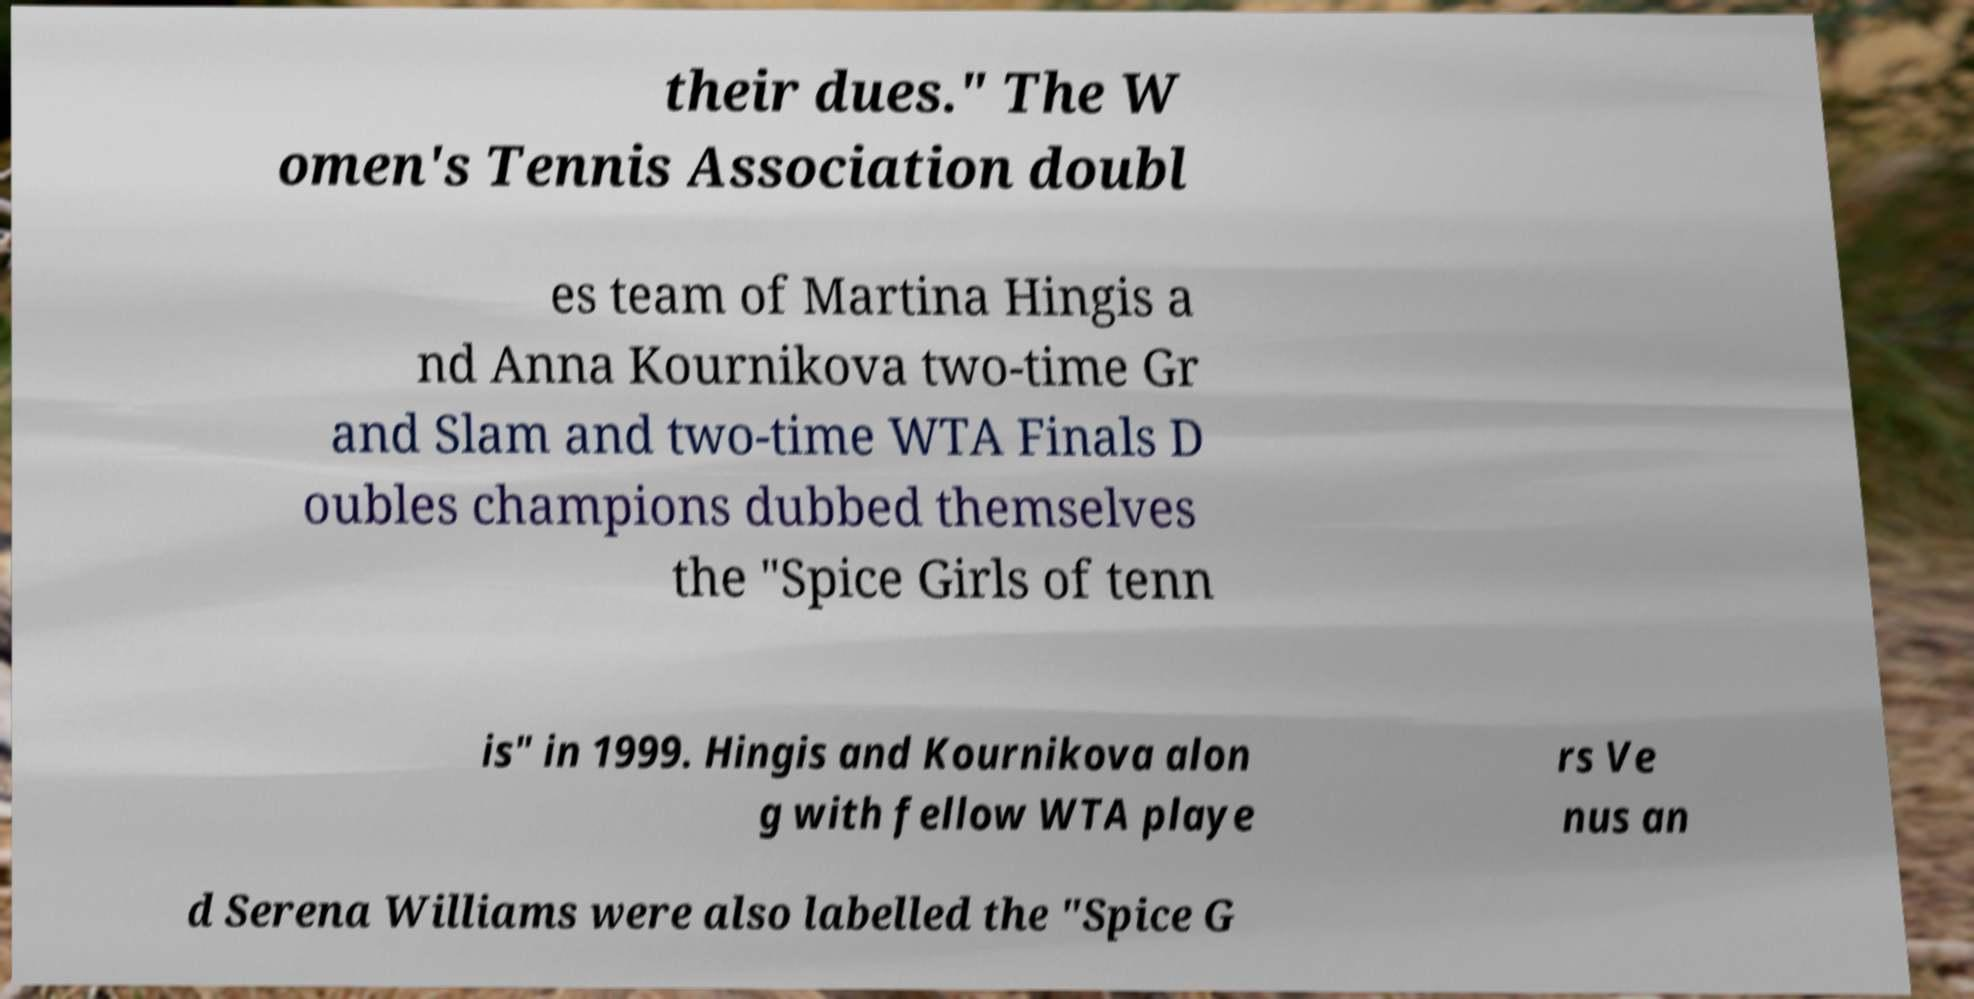Please identify and transcribe the text found in this image. their dues." The W omen's Tennis Association doubl es team of Martina Hingis a nd Anna Kournikova two-time Gr and Slam and two-time WTA Finals D oubles champions dubbed themselves the "Spice Girls of tenn is" in 1999. Hingis and Kournikova alon g with fellow WTA playe rs Ve nus an d Serena Williams were also labelled the "Spice G 